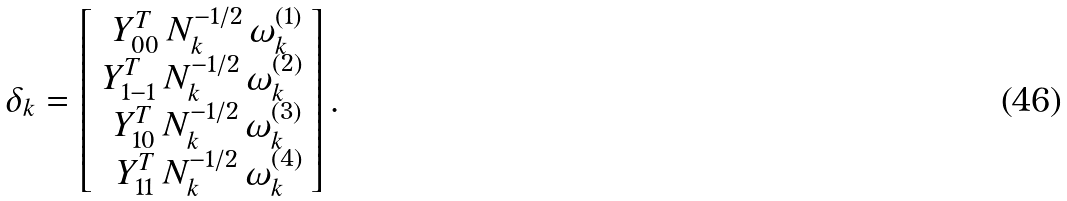Convert formula to latex. <formula><loc_0><loc_0><loc_500><loc_500>\delta _ { k } = \left [ \begin{array} { r } Y _ { 0 0 } ^ { T } \, N ^ { - 1 / 2 } _ { k } \, \omega _ { k } ^ { ( 1 ) } \\ Y _ { 1 - 1 } ^ { T } \, N ^ { - 1 / 2 } _ { k } \, \omega _ { k } ^ { ( 2 ) } \\ Y _ { 1 0 } ^ { T } \, N ^ { - 1 / 2 } _ { k } \, \omega _ { k } ^ { ( 3 ) } \\ Y _ { 1 1 } ^ { T } \, N ^ { - 1 / 2 } _ { k } \, \omega _ { k } ^ { ( 4 ) } \end{array} \right ] .</formula> 